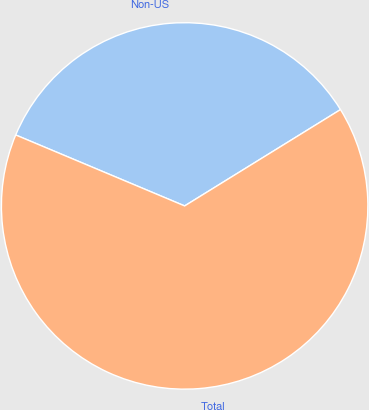<chart> <loc_0><loc_0><loc_500><loc_500><pie_chart><fcel>Non-US<fcel>Total<nl><fcel>34.86%<fcel>65.14%<nl></chart> 